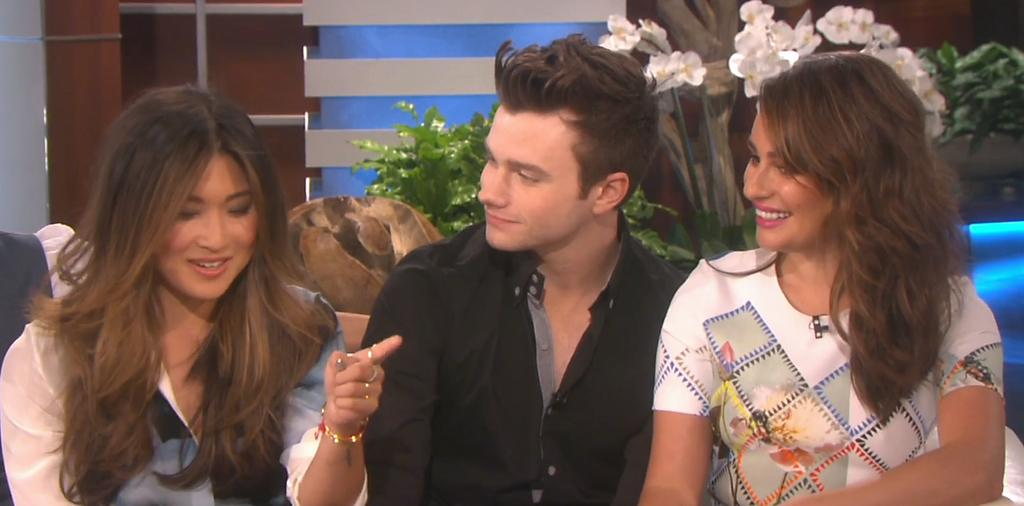What are the people in the image doing? The people in the image are sitting on chairs. What is the facial expression of the people in the image? The people are smiling. What can be seen in the background of the image? There are walls and decorative plants in the background of the image. Can you see any fairies flying around the decorative plants in the image? There are no fairies present in the image; only people, chairs, walls, and decorative plants can be seen. 